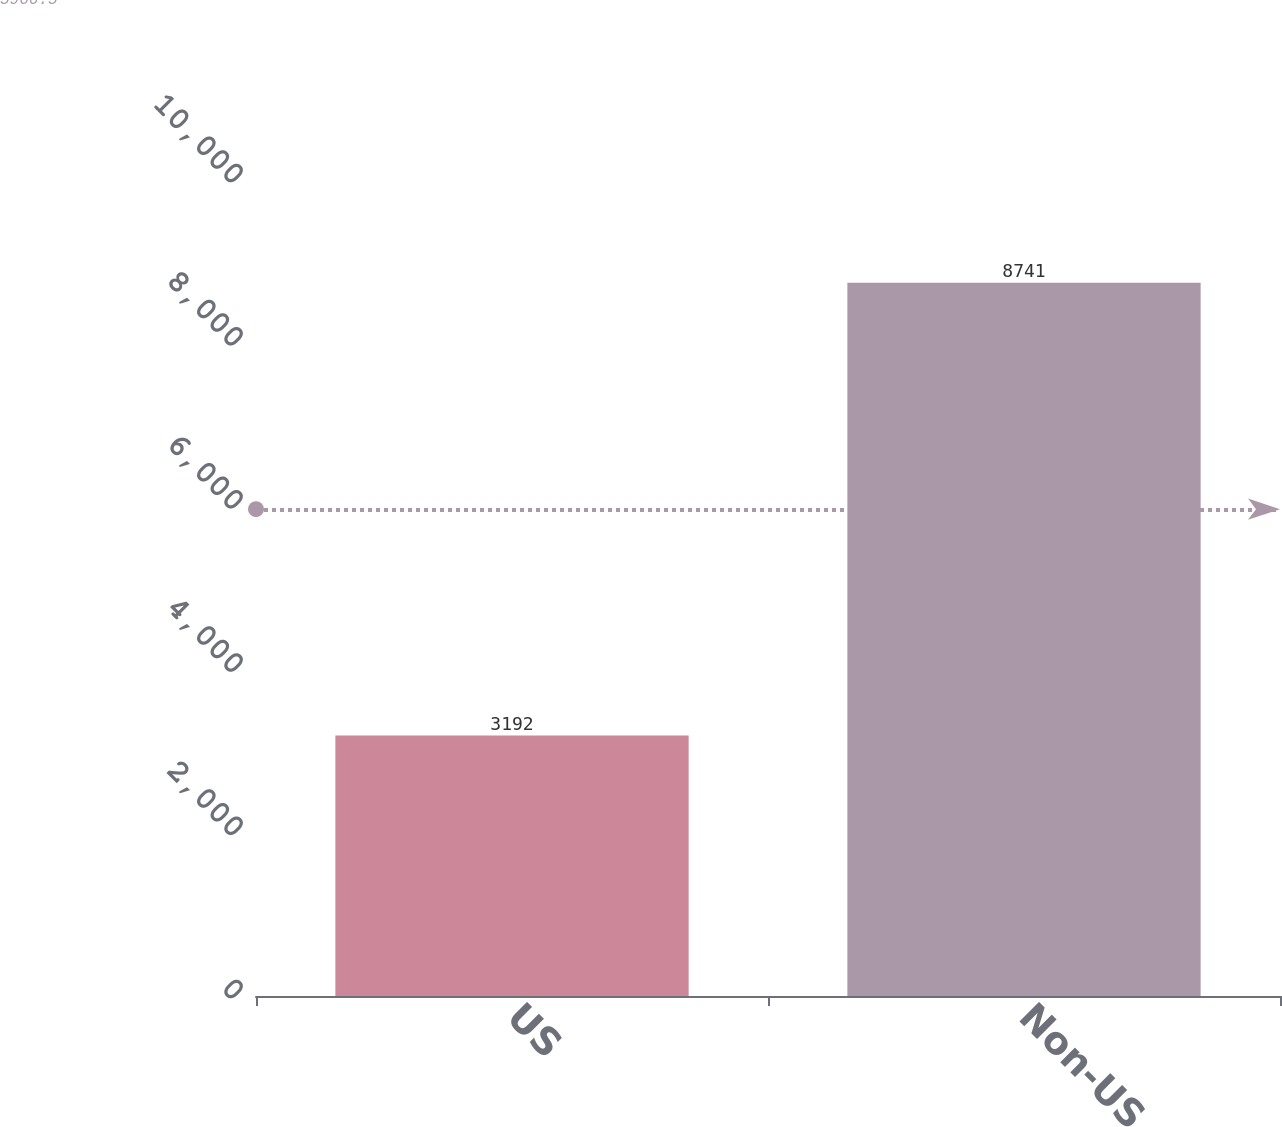Convert chart. <chart><loc_0><loc_0><loc_500><loc_500><bar_chart><fcel>US<fcel>Non-US<nl><fcel>3192<fcel>8741<nl></chart> 